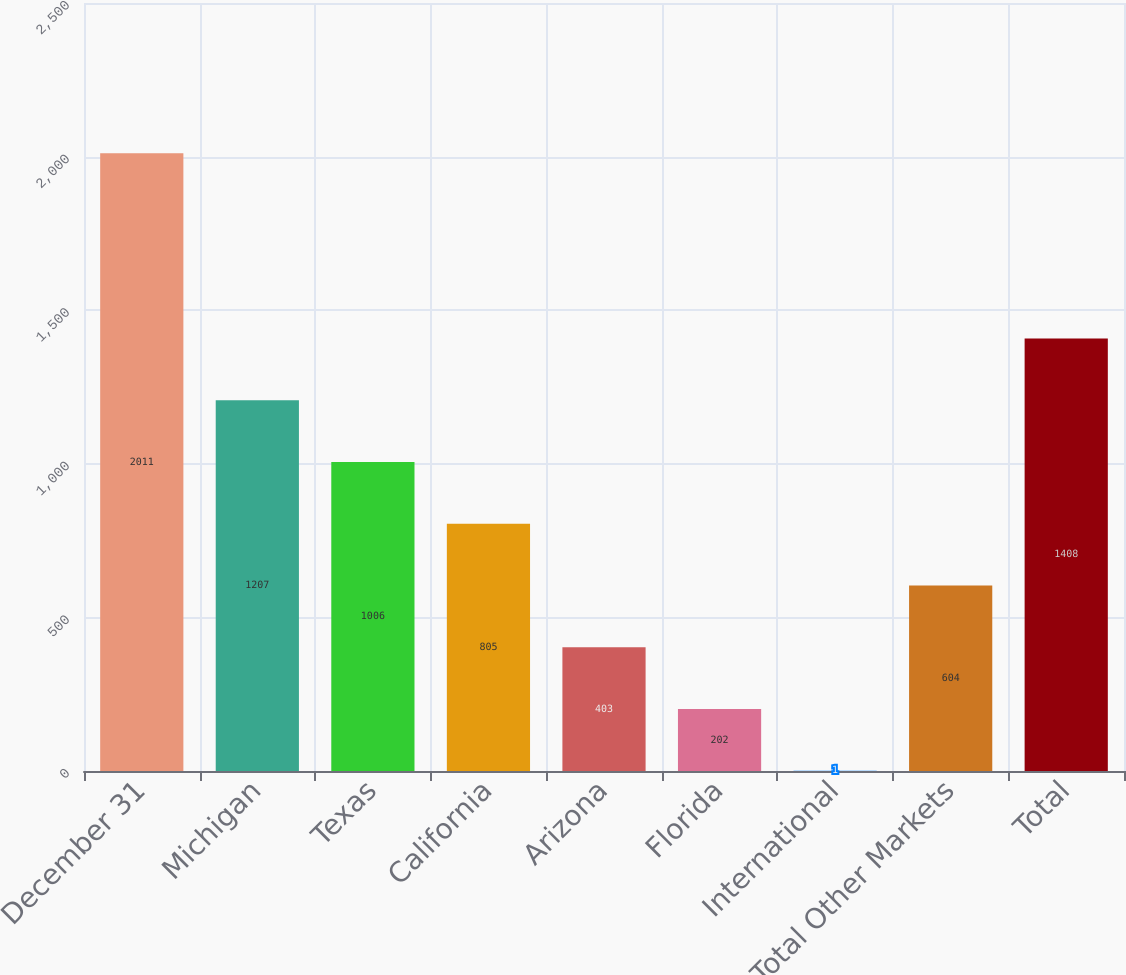Convert chart to OTSL. <chart><loc_0><loc_0><loc_500><loc_500><bar_chart><fcel>December 31<fcel>Michigan<fcel>Texas<fcel>California<fcel>Arizona<fcel>Florida<fcel>International<fcel>Total Other Markets<fcel>Total<nl><fcel>2011<fcel>1207<fcel>1006<fcel>805<fcel>403<fcel>202<fcel>1<fcel>604<fcel>1408<nl></chart> 